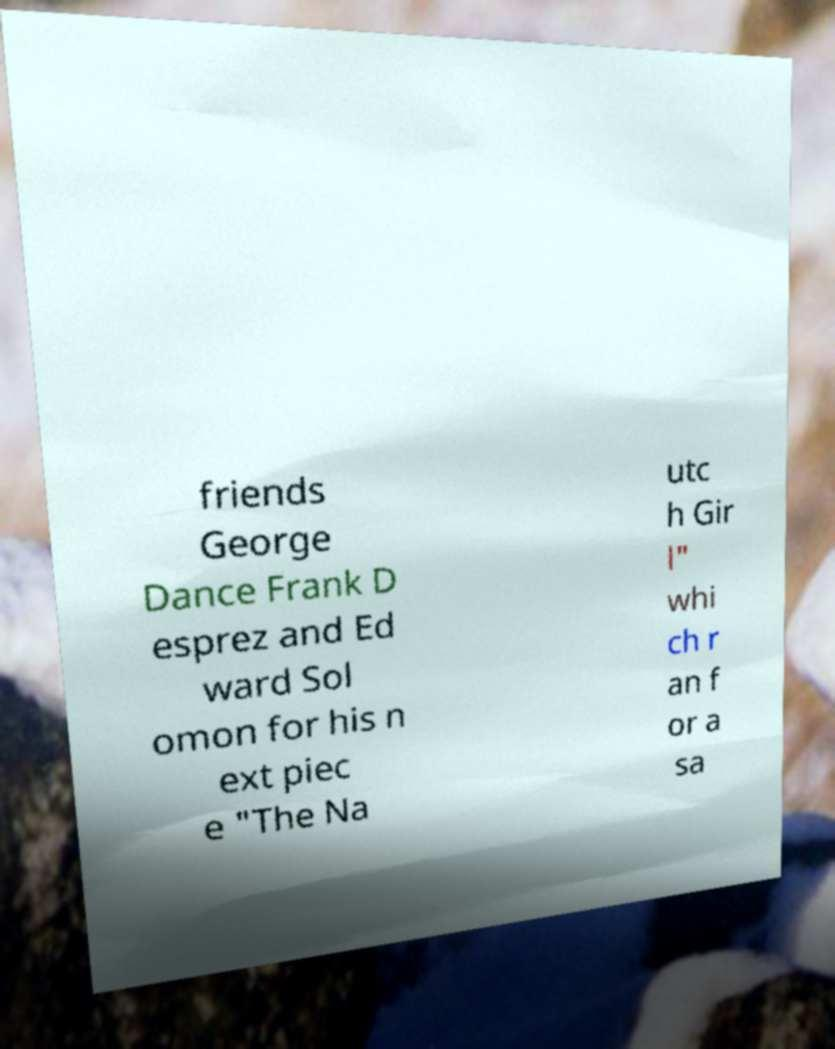Could you extract and type out the text from this image? friends George Dance Frank D esprez and Ed ward Sol omon for his n ext piec e "The Na utc h Gir l" whi ch r an f or a sa 